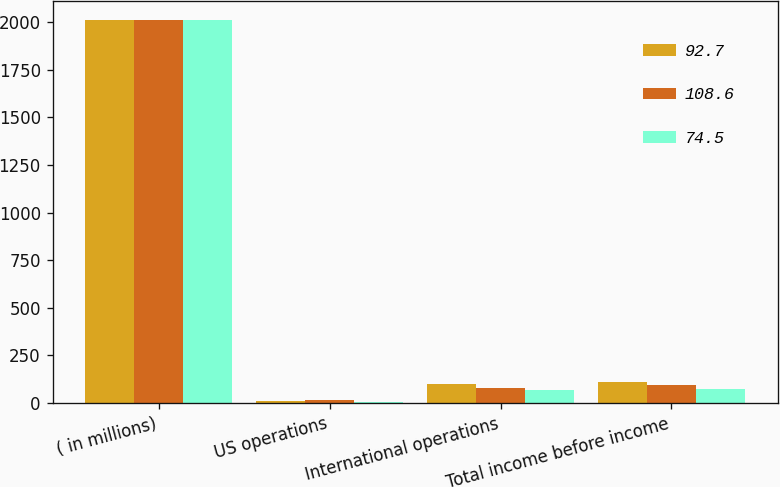<chart> <loc_0><loc_0><loc_500><loc_500><stacked_bar_chart><ecel><fcel>( in millions)<fcel>US operations<fcel>International operations<fcel>Total income before income<nl><fcel>92.7<fcel>2012<fcel>8.9<fcel>99.7<fcel>108.6<nl><fcel>108.6<fcel>2011<fcel>15.8<fcel>76.9<fcel>92.7<nl><fcel>74.5<fcel>2010<fcel>7.2<fcel>67.3<fcel>74.5<nl></chart> 